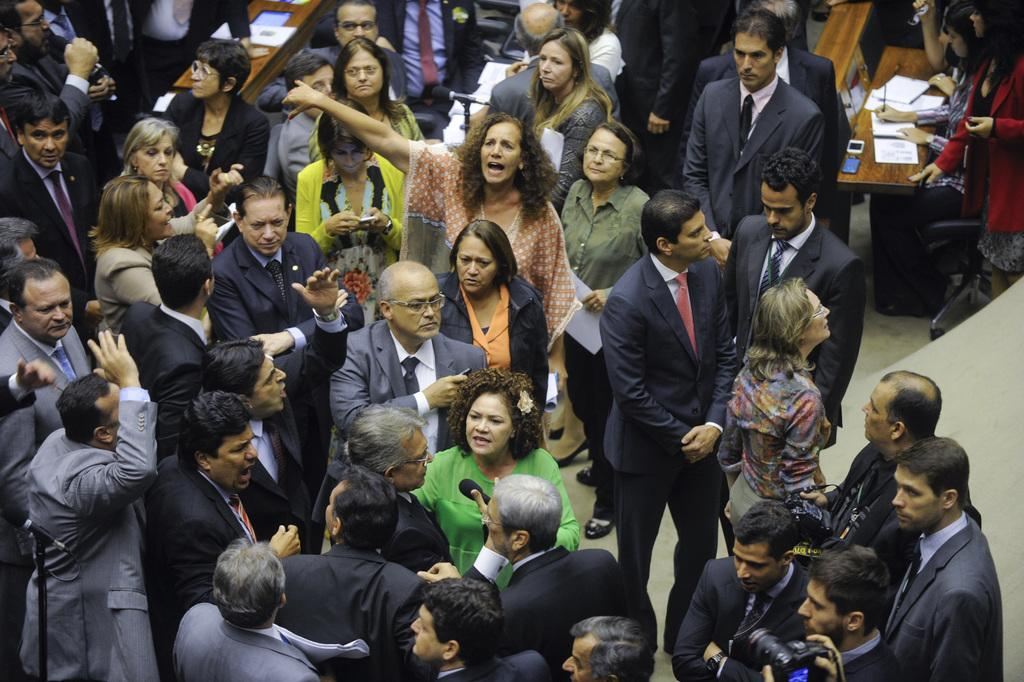What is happening in the image? There are people standing and sitting in the image. What can be seen in the background of the image? There are benches in the background of the image. What is located near the benches? Papers are near the benches. Can you describe the seating arrangement in the image? There are people sitting on chairs in the image. How does the canvas react to the earthquake in the image? There is no canvas or earthquake present in the image. 